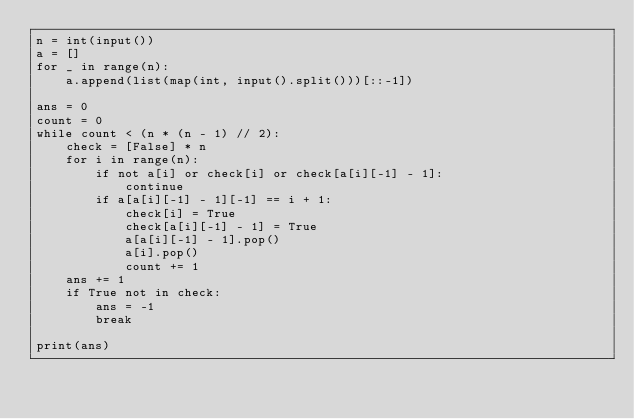<code> <loc_0><loc_0><loc_500><loc_500><_Python_>n = int(input())
a = []
for _ in range(n):
    a.append(list(map(int, input().split()))[::-1])

ans = 0
count = 0
while count < (n * (n - 1) // 2):
    check = [False] * n
    for i in range(n):
        if not a[i] or check[i] or check[a[i][-1] - 1]:
            continue
        if a[a[i][-1] - 1][-1] == i + 1:
            check[i] = True
            check[a[i][-1] - 1] = True
            a[a[i][-1] - 1].pop()
            a[i].pop()
            count += 1
    ans += 1
    if True not in check:
        ans = -1
        break

print(ans)
</code> 